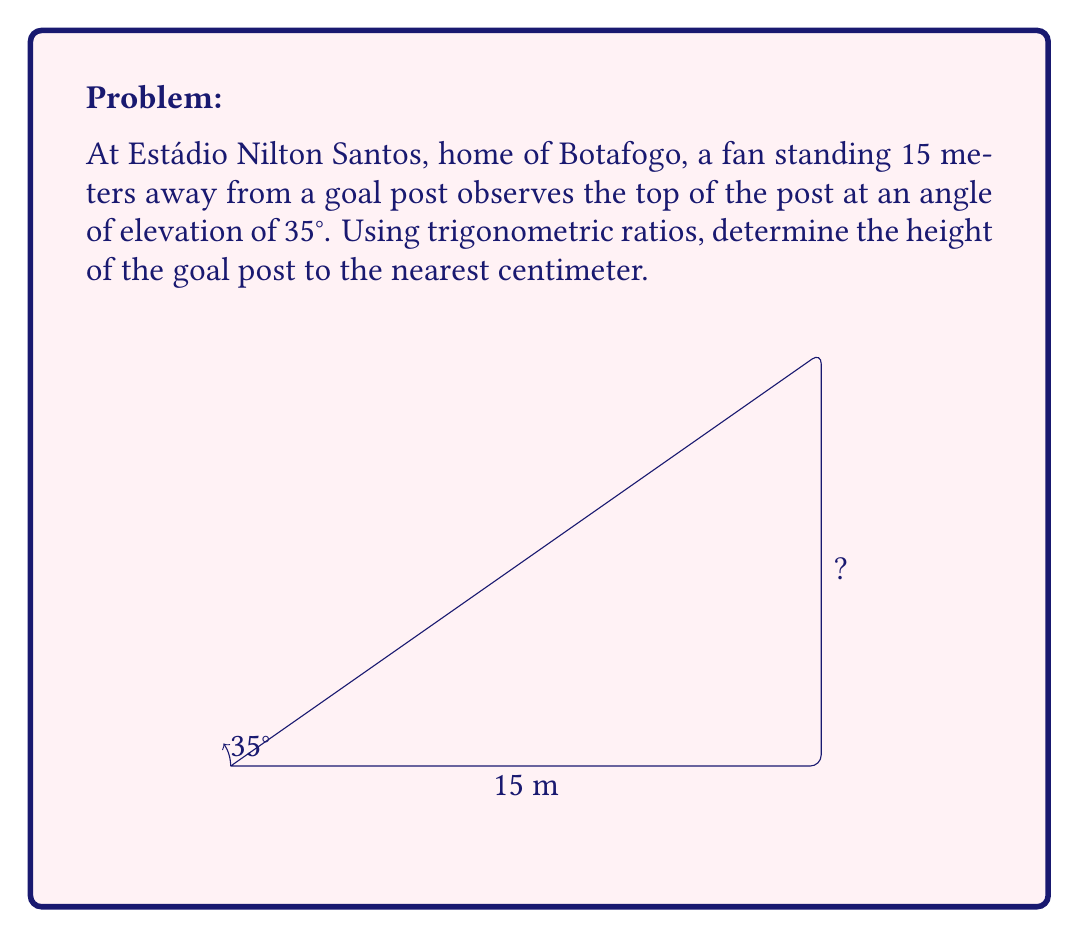Teach me how to tackle this problem. Let's approach this step-by-step:

1) In this problem, we have a right triangle where:
   - The adjacent side is the distance from the fan to the goal post (15 meters)
   - The angle of elevation is 35°
   - We need to find the opposite side, which is the height of the goal post

2) The trigonometric ratio that relates the opposite side to the adjacent side is the tangent:

   $$\tan \theta = \frac{\text{opposite}}{\text{adjacent}}$$

3) Let's call the height of the goal post $h$. We can write:

   $$\tan 35° = \frac{h}{15}$$

4) To solve for $h$, we multiply both sides by 15:

   $$15 \tan 35° = h$$

5) Now we need to calculate this:
   
   $$h = 15 \times \tan 35°$$

6) Using a calculator (or trigonometric tables):
   
   $$h = 15 \times 0.7002075$$
   
   $$h = 10.50311 \text{ meters}$$

7) Rounding to the nearest centimeter:

   $$h \approx 10.50 \text{ meters}$$

Thus, the height of the goal post is approximately 10.50 meters or 1050 centimeters.
Answer: 1050 cm 